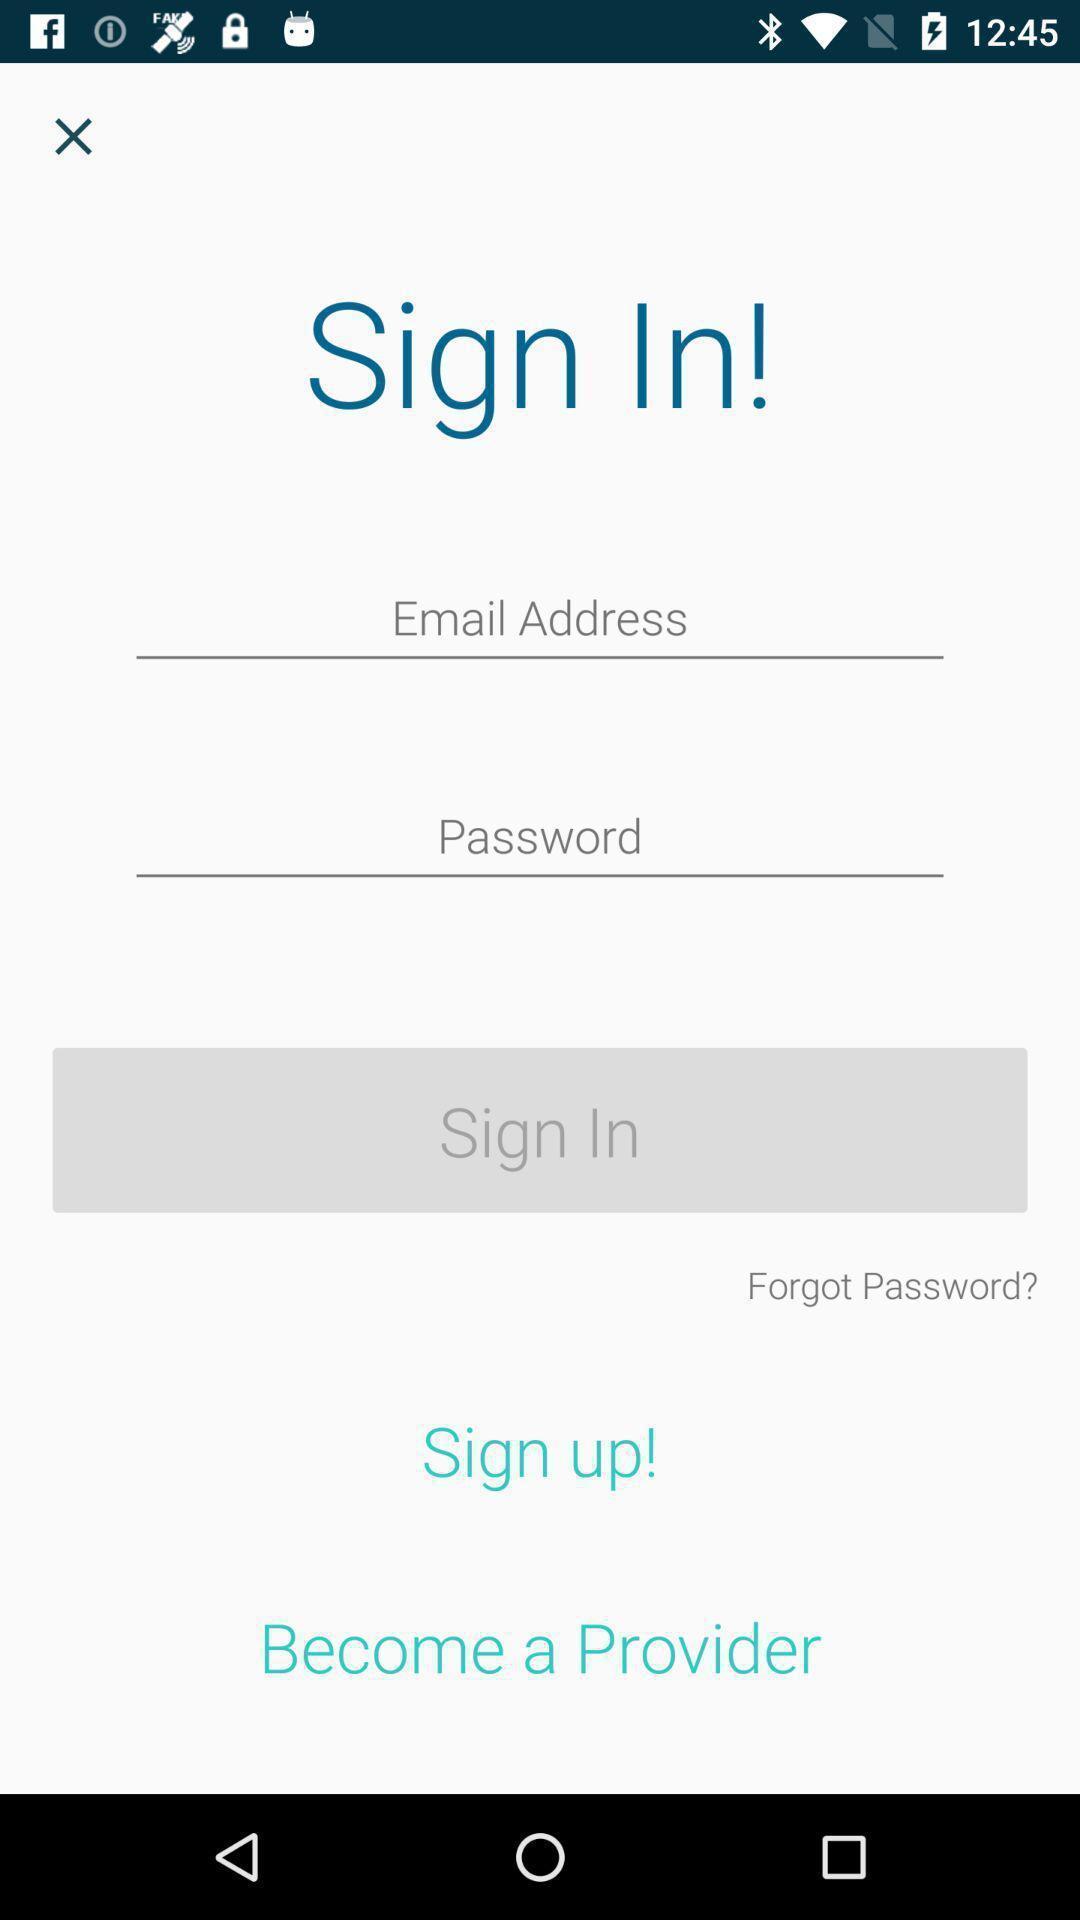Summarize the information in this screenshot. Sign-in page. 